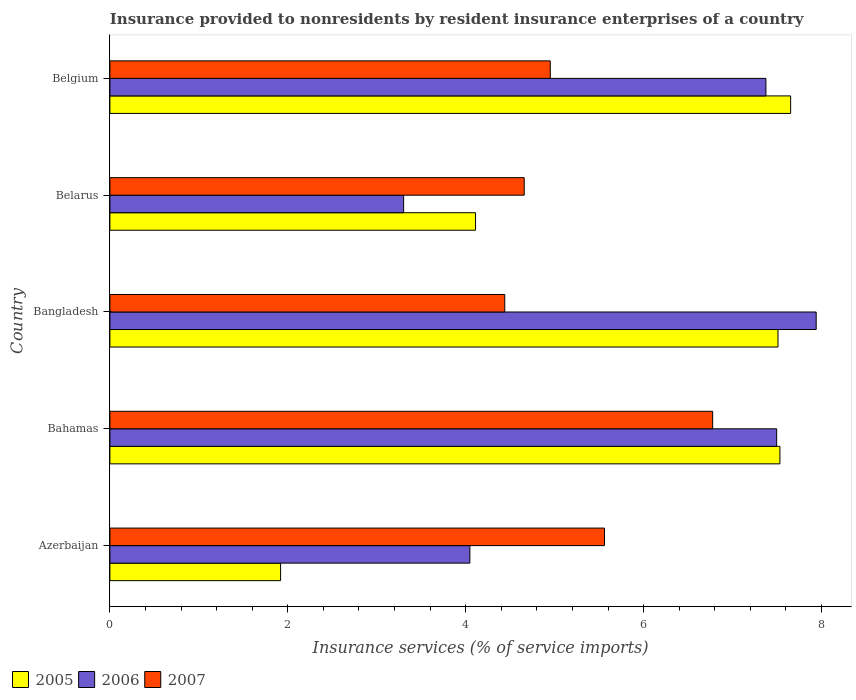How many different coloured bars are there?
Ensure brevity in your answer.  3. How many groups of bars are there?
Your answer should be very brief. 5. Are the number of bars per tick equal to the number of legend labels?
Ensure brevity in your answer.  Yes. How many bars are there on the 4th tick from the top?
Your response must be concise. 3. How many bars are there on the 5th tick from the bottom?
Ensure brevity in your answer.  3. What is the label of the 5th group of bars from the top?
Give a very brief answer. Azerbaijan. What is the insurance provided to nonresidents in 2005 in Belarus?
Keep it short and to the point. 4.11. Across all countries, what is the maximum insurance provided to nonresidents in 2006?
Provide a short and direct response. 7.94. Across all countries, what is the minimum insurance provided to nonresidents in 2006?
Your answer should be compact. 3.3. In which country was the insurance provided to nonresidents in 2005 maximum?
Your answer should be very brief. Belgium. In which country was the insurance provided to nonresidents in 2006 minimum?
Provide a short and direct response. Belarus. What is the total insurance provided to nonresidents in 2006 in the graph?
Make the answer very short. 30.16. What is the difference between the insurance provided to nonresidents in 2005 in Bangladesh and that in Belarus?
Your answer should be very brief. 3.4. What is the difference between the insurance provided to nonresidents in 2006 in Bangladesh and the insurance provided to nonresidents in 2005 in Belarus?
Keep it short and to the point. 3.83. What is the average insurance provided to nonresidents in 2007 per country?
Ensure brevity in your answer.  5.28. What is the difference between the insurance provided to nonresidents in 2007 and insurance provided to nonresidents in 2006 in Belgium?
Your answer should be very brief. -2.42. What is the ratio of the insurance provided to nonresidents in 2006 in Bahamas to that in Belarus?
Keep it short and to the point. 2.27. Is the insurance provided to nonresidents in 2005 in Bahamas less than that in Belgium?
Your answer should be very brief. Yes. Is the difference between the insurance provided to nonresidents in 2007 in Azerbaijan and Belarus greater than the difference between the insurance provided to nonresidents in 2006 in Azerbaijan and Belarus?
Keep it short and to the point. Yes. What is the difference between the highest and the second highest insurance provided to nonresidents in 2007?
Give a very brief answer. 1.22. What is the difference between the highest and the lowest insurance provided to nonresidents in 2006?
Keep it short and to the point. 4.64. In how many countries, is the insurance provided to nonresidents in 2005 greater than the average insurance provided to nonresidents in 2005 taken over all countries?
Provide a short and direct response. 3. Is the sum of the insurance provided to nonresidents in 2007 in Belarus and Belgium greater than the maximum insurance provided to nonresidents in 2006 across all countries?
Your answer should be compact. Yes. What does the 2nd bar from the top in Bahamas represents?
Your answer should be compact. 2006. What is the difference between two consecutive major ticks on the X-axis?
Make the answer very short. 2. Are the values on the major ticks of X-axis written in scientific E-notation?
Provide a short and direct response. No. Does the graph contain any zero values?
Provide a short and direct response. No. Where does the legend appear in the graph?
Your answer should be compact. Bottom left. What is the title of the graph?
Offer a terse response. Insurance provided to nonresidents by resident insurance enterprises of a country. Does "1999" appear as one of the legend labels in the graph?
Make the answer very short. No. What is the label or title of the X-axis?
Keep it short and to the point. Insurance services (% of service imports). What is the label or title of the Y-axis?
Offer a terse response. Country. What is the Insurance services (% of service imports) in 2005 in Azerbaijan?
Your answer should be compact. 1.92. What is the Insurance services (% of service imports) in 2006 in Azerbaijan?
Offer a terse response. 4.05. What is the Insurance services (% of service imports) in 2007 in Azerbaijan?
Your response must be concise. 5.56. What is the Insurance services (% of service imports) of 2005 in Bahamas?
Keep it short and to the point. 7.53. What is the Insurance services (% of service imports) in 2006 in Bahamas?
Make the answer very short. 7.5. What is the Insurance services (% of service imports) in 2007 in Bahamas?
Provide a succinct answer. 6.78. What is the Insurance services (% of service imports) in 2005 in Bangladesh?
Your answer should be compact. 7.51. What is the Insurance services (% of service imports) in 2006 in Bangladesh?
Your response must be concise. 7.94. What is the Insurance services (% of service imports) of 2007 in Bangladesh?
Make the answer very short. 4.44. What is the Insurance services (% of service imports) of 2005 in Belarus?
Keep it short and to the point. 4.11. What is the Insurance services (% of service imports) of 2006 in Belarus?
Offer a terse response. 3.3. What is the Insurance services (% of service imports) of 2007 in Belarus?
Ensure brevity in your answer.  4.66. What is the Insurance services (% of service imports) in 2005 in Belgium?
Offer a very short reply. 7.65. What is the Insurance services (% of service imports) of 2006 in Belgium?
Your answer should be compact. 7.37. What is the Insurance services (% of service imports) of 2007 in Belgium?
Offer a very short reply. 4.95. Across all countries, what is the maximum Insurance services (% of service imports) in 2005?
Your answer should be compact. 7.65. Across all countries, what is the maximum Insurance services (% of service imports) of 2006?
Give a very brief answer. 7.94. Across all countries, what is the maximum Insurance services (% of service imports) in 2007?
Your answer should be very brief. 6.78. Across all countries, what is the minimum Insurance services (% of service imports) of 2005?
Ensure brevity in your answer.  1.92. Across all countries, what is the minimum Insurance services (% of service imports) of 2006?
Offer a terse response. 3.3. Across all countries, what is the minimum Insurance services (% of service imports) in 2007?
Ensure brevity in your answer.  4.44. What is the total Insurance services (% of service imports) of 2005 in the graph?
Keep it short and to the point. 28.72. What is the total Insurance services (% of service imports) in 2006 in the graph?
Offer a very short reply. 30.16. What is the total Insurance services (% of service imports) in 2007 in the graph?
Provide a short and direct response. 26.38. What is the difference between the Insurance services (% of service imports) in 2005 in Azerbaijan and that in Bahamas?
Offer a very short reply. -5.61. What is the difference between the Insurance services (% of service imports) of 2006 in Azerbaijan and that in Bahamas?
Your answer should be compact. -3.45. What is the difference between the Insurance services (% of service imports) of 2007 in Azerbaijan and that in Bahamas?
Give a very brief answer. -1.22. What is the difference between the Insurance services (% of service imports) of 2005 in Azerbaijan and that in Bangladesh?
Your response must be concise. -5.59. What is the difference between the Insurance services (% of service imports) in 2006 in Azerbaijan and that in Bangladesh?
Ensure brevity in your answer.  -3.89. What is the difference between the Insurance services (% of service imports) of 2007 in Azerbaijan and that in Bangladesh?
Your answer should be very brief. 1.12. What is the difference between the Insurance services (% of service imports) of 2005 in Azerbaijan and that in Belarus?
Provide a short and direct response. -2.19. What is the difference between the Insurance services (% of service imports) in 2006 in Azerbaijan and that in Belarus?
Your response must be concise. 0.74. What is the difference between the Insurance services (% of service imports) in 2007 in Azerbaijan and that in Belarus?
Give a very brief answer. 0.9. What is the difference between the Insurance services (% of service imports) in 2005 in Azerbaijan and that in Belgium?
Your answer should be very brief. -5.73. What is the difference between the Insurance services (% of service imports) of 2006 in Azerbaijan and that in Belgium?
Your answer should be very brief. -3.33. What is the difference between the Insurance services (% of service imports) in 2007 in Azerbaijan and that in Belgium?
Your answer should be very brief. 0.61. What is the difference between the Insurance services (% of service imports) in 2005 in Bahamas and that in Bangladesh?
Your answer should be very brief. 0.02. What is the difference between the Insurance services (% of service imports) in 2006 in Bahamas and that in Bangladesh?
Your answer should be very brief. -0.44. What is the difference between the Insurance services (% of service imports) in 2007 in Bahamas and that in Bangladesh?
Provide a succinct answer. 2.34. What is the difference between the Insurance services (% of service imports) of 2005 in Bahamas and that in Belarus?
Your answer should be compact. 3.42. What is the difference between the Insurance services (% of service imports) in 2006 in Bahamas and that in Belarus?
Your answer should be very brief. 4.19. What is the difference between the Insurance services (% of service imports) of 2007 in Bahamas and that in Belarus?
Offer a terse response. 2.12. What is the difference between the Insurance services (% of service imports) of 2005 in Bahamas and that in Belgium?
Your answer should be compact. -0.12. What is the difference between the Insurance services (% of service imports) in 2006 in Bahamas and that in Belgium?
Provide a short and direct response. 0.12. What is the difference between the Insurance services (% of service imports) in 2007 in Bahamas and that in Belgium?
Provide a succinct answer. 1.83. What is the difference between the Insurance services (% of service imports) of 2006 in Bangladesh and that in Belarus?
Your answer should be compact. 4.64. What is the difference between the Insurance services (% of service imports) in 2007 in Bangladesh and that in Belarus?
Offer a very short reply. -0.22. What is the difference between the Insurance services (% of service imports) of 2005 in Bangladesh and that in Belgium?
Offer a terse response. -0.14. What is the difference between the Insurance services (% of service imports) of 2006 in Bangladesh and that in Belgium?
Ensure brevity in your answer.  0.57. What is the difference between the Insurance services (% of service imports) of 2007 in Bangladesh and that in Belgium?
Ensure brevity in your answer.  -0.51. What is the difference between the Insurance services (% of service imports) of 2005 in Belarus and that in Belgium?
Keep it short and to the point. -3.54. What is the difference between the Insurance services (% of service imports) in 2006 in Belarus and that in Belgium?
Your response must be concise. -4.07. What is the difference between the Insurance services (% of service imports) of 2007 in Belarus and that in Belgium?
Provide a succinct answer. -0.29. What is the difference between the Insurance services (% of service imports) in 2005 in Azerbaijan and the Insurance services (% of service imports) in 2006 in Bahamas?
Your response must be concise. -5.58. What is the difference between the Insurance services (% of service imports) in 2005 in Azerbaijan and the Insurance services (% of service imports) in 2007 in Bahamas?
Your response must be concise. -4.86. What is the difference between the Insurance services (% of service imports) in 2006 in Azerbaijan and the Insurance services (% of service imports) in 2007 in Bahamas?
Your response must be concise. -2.73. What is the difference between the Insurance services (% of service imports) of 2005 in Azerbaijan and the Insurance services (% of service imports) of 2006 in Bangladesh?
Give a very brief answer. -6.02. What is the difference between the Insurance services (% of service imports) in 2005 in Azerbaijan and the Insurance services (% of service imports) in 2007 in Bangladesh?
Offer a terse response. -2.52. What is the difference between the Insurance services (% of service imports) in 2006 in Azerbaijan and the Insurance services (% of service imports) in 2007 in Bangladesh?
Make the answer very short. -0.39. What is the difference between the Insurance services (% of service imports) of 2005 in Azerbaijan and the Insurance services (% of service imports) of 2006 in Belarus?
Provide a succinct answer. -1.38. What is the difference between the Insurance services (% of service imports) of 2005 in Azerbaijan and the Insurance services (% of service imports) of 2007 in Belarus?
Offer a terse response. -2.74. What is the difference between the Insurance services (% of service imports) of 2006 in Azerbaijan and the Insurance services (% of service imports) of 2007 in Belarus?
Provide a short and direct response. -0.61. What is the difference between the Insurance services (% of service imports) of 2005 in Azerbaijan and the Insurance services (% of service imports) of 2006 in Belgium?
Keep it short and to the point. -5.46. What is the difference between the Insurance services (% of service imports) of 2005 in Azerbaijan and the Insurance services (% of service imports) of 2007 in Belgium?
Make the answer very short. -3.03. What is the difference between the Insurance services (% of service imports) of 2006 in Azerbaijan and the Insurance services (% of service imports) of 2007 in Belgium?
Give a very brief answer. -0.9. What is the difference between the Insurance services (% of service imports) of 2005 in Bahamas and the Insurance services (% of service imports) of 2006 in Bangladesh?
Your answer should be very brief. -0.41. What is the difference between the Insurance services (% of service imports) in 2005 in Bahamas and the Insurance services (% of service imports) in 2007 in Bangladesh?
Provide a succinct answer. 3.09. What is the difference between the Insurance services (% of service imports) of 2006 in Bahamas and the Insurance services (% of service imports) of 2007 in Bangladesh?
Give a very brief answer. 3.06. What is the difference between the Insurance services (% of service imports) in 2005 in Bahamas and the Insurance services (% of service imports) in 2006 in Belarus?
Make the answer very short. 4.23. What is the difference between the Insurance services (% of service imports) of 2005 in Bahamas and the Insurance services (% of service imports) of 2007 in Belarus?
Provide a succinct answer. 2.87. What is the difference between the Insurance services (% of service imports) of 2006 in Bahamas and the Insurance services (% of service imports) of 2007 in Belarus?
Ensure brevity in your answer.  2.84. What is the difference between the Insurance services (% of service imports) in 2005 in Bahamas and the Insurance services (% of service imports) in 2006 in Belgium?
Offer a terse response. 0.16. What is the difference between the Insurance services (% of service imports) of 2005 in Bahamas and the Insurance services (% of service imports) of 2007 in Belgium?
Provide a succinct answer. 2.58. What is the difference between the Insurance services (% of service imports) of 2006 in Bahamas and the Insurance services (% of service imports) of 2007 in Belgium?
Provide a short and direct response. 2.54. What is the difference between the Insurance services (% of service imports) in 2005 in Bangladesh and the Insurance services (% of service imports) in 2006 in Belarus?
Your answer should be compact. 4.21. What is the difference between the Insurance services (% of service imports) in 2005 in Bangladesh and the Insurance services (% of service imports) in 2007 in Belarus?
Ensure brevity in your answer.  2.85. What is the difference between the Insurance services (% of service imports) in 2006 in Bangladesh and the Insurance services (% of service imports) in 2007 in Belarus?
Your answer should be very brief. 3.28. What is the difference between the Insurance services (% of service imports) of 2005 in Bangladesh and the Insurance services (% of service imports) of 2006 in Belgium?
Provide a short and direct response. 0.14. What is the difference between the Insurance services (% of service imports) of 2005 in Bangladesh and the Insurance services (% of service imports) of 2007 in Belgium?
Offer a very short reply. 2.56. What is the difference between the Insurance services (% of service imports) of 2006 in Bangladesh and the Insurance services (% of service imports) of 2007 in Belgium?
Make the answer very short. 2.99. What is the difference between the Insurance services (% of service imports) of 2005 in Belarus and the Insurance services (% of service imports) of 2006 in Belgium?
Provide a short and direct response. -3.26. What is the difference between the Insurance services (% of service imports) in 2005 in Belarus and the Insurance services (% of service imports) in 2007 in Belgium?
Offer a very short reply. -0.84. What is the difference between the Insurance services (% of service imports) of 2006 in Belarus and the Insurance services (% of service imports) of 2007 in Belgium?
Ensure brevity in your answer.  -1.65. What is the average Insurance services (% of service imports) of 2005 per country?
Offer a terse response. 5.74. What is the average Insurance services (% of service imports) of 2006 per country?
Your response must be concise. 6.03. What is the average Insurance services (% of service imports) in 2007 per country?
Offer a very short reply. 5.28. What is the difference between the Insurance services (% of service imports) in 2005 and Insurance services (% of service imports) in 2006 in Azerbaijan?
Your answer should be very brief. -2.13. What is the difference between the Insurance services (% of service imports) in 2005 and Insurance services (% of service imports) in 2007 in Azerbaijan?
Offer a very short reply. -3.64. What is the difference between the Insurance services (% of service imports) of 2006 and Insurance services (% of service imports) of 2007 in Azerbaijan?
Provide a short and direct response. -1.51. What is the difference between the Insurance services (% of service imports) in 2005 and Insurance services (% of service imports) in 2006 in Bahamas?
Make the answer very short. 0.04. What is the difference between the Insurance services (% of service imports) in 2005 and Insurance services (% of service imports) in 2007 in Bahamas?
Offer a terse response. 0.76. What is the difference between the Insurance services (% of service imports) in 2006 and Insurance services (% of service imports) in 2007 in Bahamas?
Offer a terse response. 0.72. What is the difference between the Insurance services (% of service imports) of 2005 and Insurance services (% of service imports) of 2006 in Bangladesh?
Ensure brevity in your answer.  -0.43. What is the difference between the Insurance services (% of service imports) in 2005 and Insurance services (% of service imports) in 2007 in Bangladesh?
Offer a very short reply. 3.07. What is the difference between the Insurance services (% of service imports) of 2006 and Insurance services (% of service imports) of 2007 in Bangladesh?
Provide a succinct answer. 3.5. What is the difference between the Insurance services (% of service imports) of 2005 and Insurance services (% of service imports) of 2006 in Belarus?
Your answer should be very brief. 0.81. What is the difference between the Insurance services (% of service imports) of 2005 and Insurance services (% of service imports) of 2007 in Belarus?
Ensure brevity in your answer.  -0.55. What is the difference between the Insurance services (% of service imports) in 2006 and Insurance services (% of service imports) in 2007 in Belarus?
Give a very brief answer. -1.36. What is the difference between the Insurance services (% of service imports) of 2005 and Insurance services (% of service imports) of 2006 in Belgium?
Your answer should be compact. 0.28. What is the difference between the Insurance services (% of service imports) in 2005 and Insurance services (% of service imports) in 2007 in Belgium?
Provide a short and direct response. 2.7. What is the difference between the Insurance services (% of service imports) in 2006 and Insurance services (% of service imports) in 2007 in Belgium?
Offer a very short reply. 2.42. What is the ratio of the Insurance services (% of service imports) of 2005 in Azerbaijan to that in Bahamas?
Ensure brevity in your answer.  0.25. What is the ratio of the Insurance services (% of service imports) in 2006 in Azerbaijan to that in Bahamas?
Your answer should be compact. 0.54. What is the ratio of the Insurance services (% of service imports) of 2007 in Azerbaijan to that in Bahamas?
Your answer should be compact. 0.82. What is the ratio of the Insurance services (% of service imports) in 2005 in Azerbaijan to that in Bangladesh?
Your response must be concise. 0.26. What is the ratio of the Insurance services (% of service imports) in 2006 in Azerbaijan to that in Bangladesh?
Provide a succinct answer. 0.51. What is the ratio of the Insurance services (% of service imports) of 2007 in Azerbaijan to that in Bangladesh?
Provide a succinct answer. 1.25. What is the ratio of the Insurance services (% of service imports) of 2005 in Azerbaijan to that in Belarus?
Make the answer very short. 0.47. What is the ratio of the Insurance services (% of service imports) in 2006 in Azerbaijan to that in Belarus?
Provide a short and direct response. 1.23. What is the ratio of the Insurance services (% of service imports) in 2007 in Azerbaijan to that in Belarus?
Your response must be concise. 1.19. What is the ratio of the Insurance services (% of service imports) of 2005 in Azerbaijan to that in Belgium?
Offer a terse response. 0.25. What is the ratio of the Insurance services (% of service imports) of 2006 in Azerbaijan to that in Belgium?
Your response must be concise. 0.55. What is the ratio of the Insurance services (% of service imports) of 2007 in Azerbaijan to that in Belgium?
Provide a succinct answer. 1.12. What is the ratio of the Insurance services (% of service imports) of 2005 in Bahamas to that in Bangladesh?
Ensure brevity in your answer.  1. What is the ratio of the Insurance services (% of service imports) of 2006 in Bahamas to that in Bangladesh?
Offer a very short reply. 0.94. What is the ratio of the Insurance services (% of service imports) in 2007 in Bahamas to that in Bangladesh?
Your response must be concise. 1.53. What is the ratio of the Insurance services (% of service imports) in 2005 in Bahamas to that in Belarus?
Make the answer very short. 1.83. What is the ratio of the Insurance services (% of service imports) of 2006 in Bahamas to that in Belarus?
Offer a terse response. 2.27. What is the ratio of the Insurance services (% of service imports) in 2007 in Bahamas to that in Belarus?
Make the answer very short. 1.45. What is the ratio of the Insurance services (% of service imports) of 2005 in Bahamas to that in Belgium?
Your response must be concise. 0.98. What is the ratio of the Insurance services (% of service imports) of 2006 in Bahamas to that in Belgium?
Give a very brief answer. 1.02. What is the ratio of the Insurance services (% of service imports) in 2007 in Bahamas to that in Belgium?
Give a very brief answer. 1.37. What is the ratio of the Insurance services (% of service imports) in 2005 in Bangladesh to that in Belarus?
Provide a succinct answer. 1.83. What is the ratio of the Insurance services (% of service imports) in 2006 in Bangladesh to that in Belarus?
Give a very brief answer. 2.4. What is the ratio of the Insurance services (% of service imports) in 2007 in Bangladesh to that in Belarus?
Offer a terse response. 0.95. What is the ratio of the Insurance services (% of service imports) in 2005 in Bangladesh to that in Belgium?
Ensure brevity in your answer.  0.98. What is the ratio of the Insurance services (% of service imports) of 2006 in Bangladesh to that in Belgium?
Provide a succinct answer. 1.08. What is the ratio of the Insurance services (% of service imports) in 2007 in Bangladesh to that in Belgium?
Keep it short and to the point. 0.9. What is the ratio of the Insurance services (% of service imports) of 2005 in Belarus to that in Belgium?
Your answer should be compact. 0.54. What is the ratio of the Insurance services (% of service imports) of 2006 in Belarus to that in Belgium?
Provide a short and direct response. 0.45. What is the ratio of the Insurance services (% of service imports) in 2007 in Belarus to that in Belgium?
Your answer should be very brief. 0.94. What is the difference between the highest and the second highest Insurance services (% of service imports) of 2005?
Keep it short and to the point. 0.12. What is the difference between the highest and the second highest Insurance services (% of service imports) of 2006?
Offer a very short reply. 0.44. What is the difference between the highest and the second highest Insurance services (% of service imports) in 2007?
Ensure brevity in your answer.  1.22. What is the difference between the highest and the lowest Insurance services (% of service imports) of 2005?
Make the answer very short. 5.73. What is the difference between the highest and the lowest Insurance services (% of service imports) of 2006?
Your response must be concise. 4.64. What is the difference between the highest and the lowest Insurance services (% of service imports) in 2007?
Offer a very short reply. 2.34. 